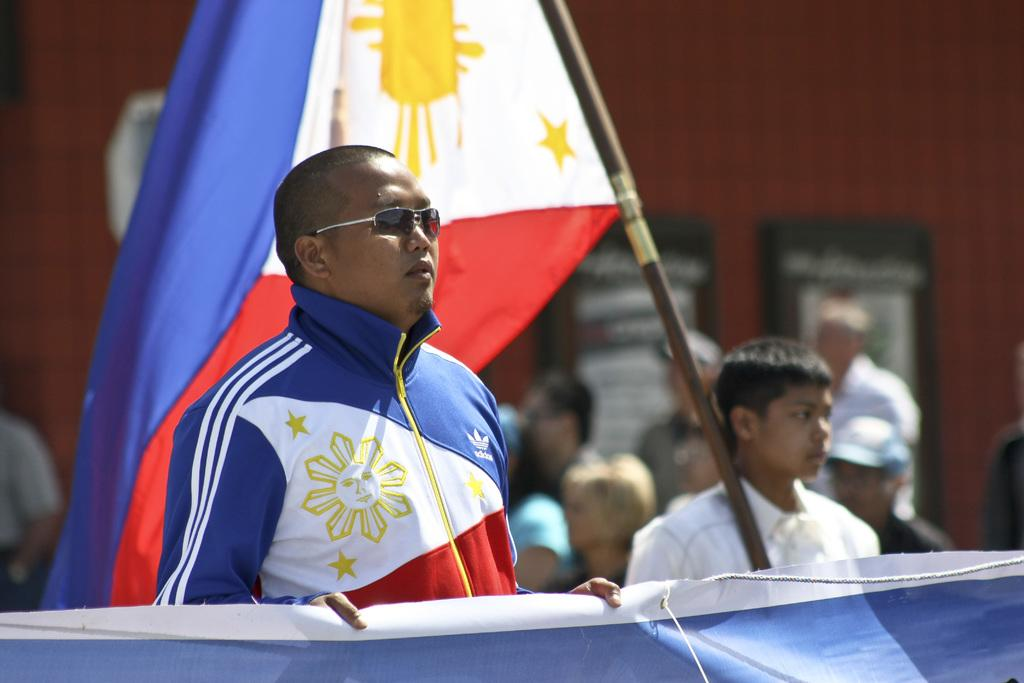What is the main subject of the image? There is a person standing in the image. What is the person wearing? The person is wearing goggles. Can you describe the other person in the image? There is another boy on the right side of the image, and he is holding a flag. What is at the bottom of the image? There is a banner at the bottom of the image. What type of creature can be seen in the background of the image? There is no creature visible in the background of the image. What industry is represented by the banner at the bottom of the image? The provided facts do not mention any specific industry related to the banner. 